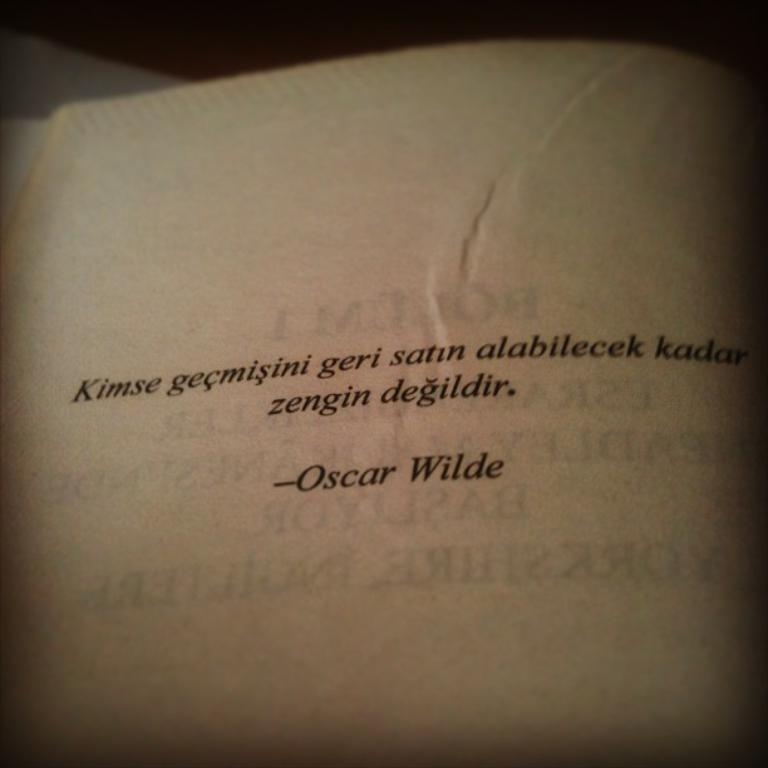<image>
Render a clear and concise summary of the photo. A German quote from Oscar Wilde on the page of a book. 